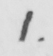Transcribe the text shown in this historical manuscript line. 1 . 